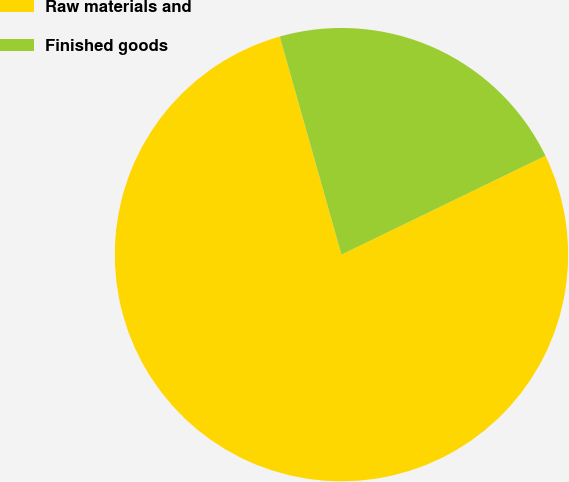Convert chart. <chart><loc_0><loc_0><loc_500><loc_500><pie_chart><fcel>Raw materials and<fcel>Finished goods<nl><fcel>77.79%<fcel>22.21%<nl></chart> 